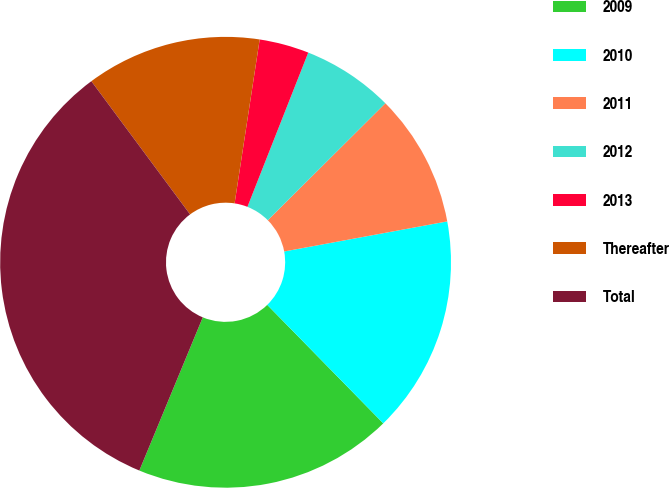<chart> <loc_0><loc_0><loc_500><loc_500><pie_chart><fcel>2009<fcel>2010<fcel>2011<fcel>2012<fcel>2013<fcel>Thereafter<fcel>Total<nl><fcel>18.58%<fcel>15.57%<fcel>9.56%<fcel>6.56%<fcel>3.56%<fcel>12.57%<fcel>33.6%<nl></chart> 